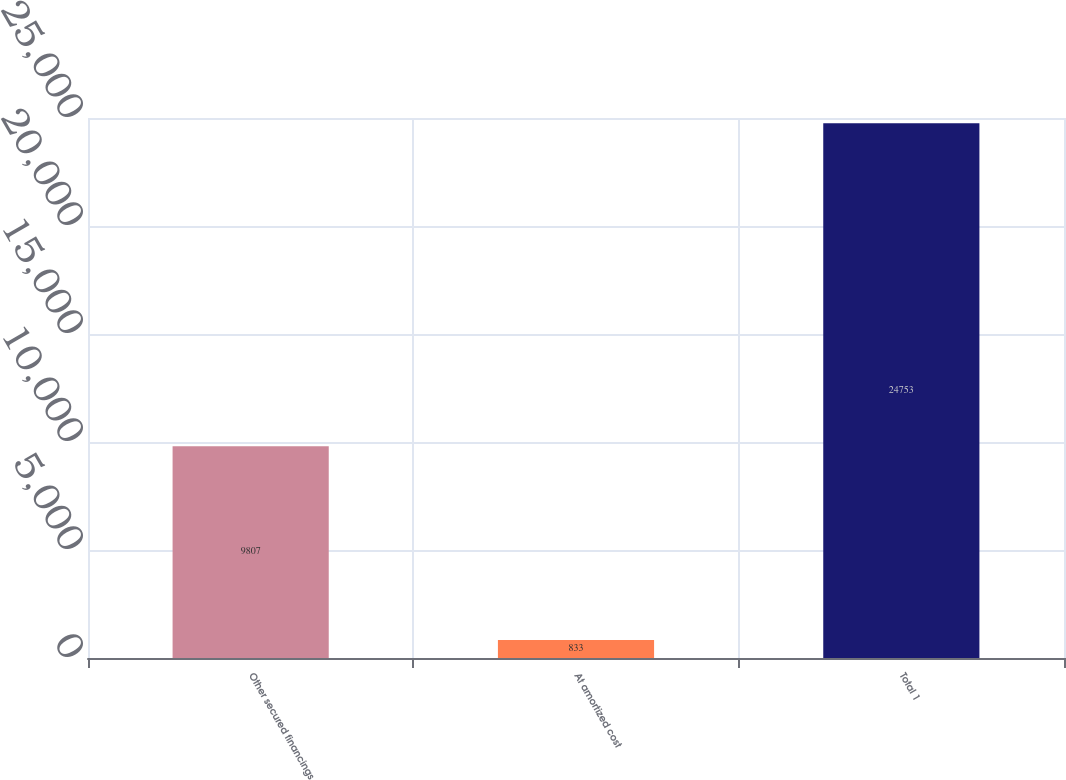Convert chart to OTSL. <chart><loc_0><loc_0><loc_500><loc_500><bar_chart><fcel>Other secured financings<fcel>At amortized cost<fcel>Total 1<nl><fcel>9807<fcel>833<fcel>24753<nl></chart> 